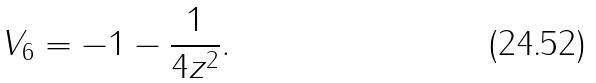Convert formula to latex. <formula><loc_0><loc_0><loc_500><loc_500>V _ { 6 } = - 1 - \frac { 1 } { 4 z ^ { 2 } } .</formula> 